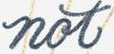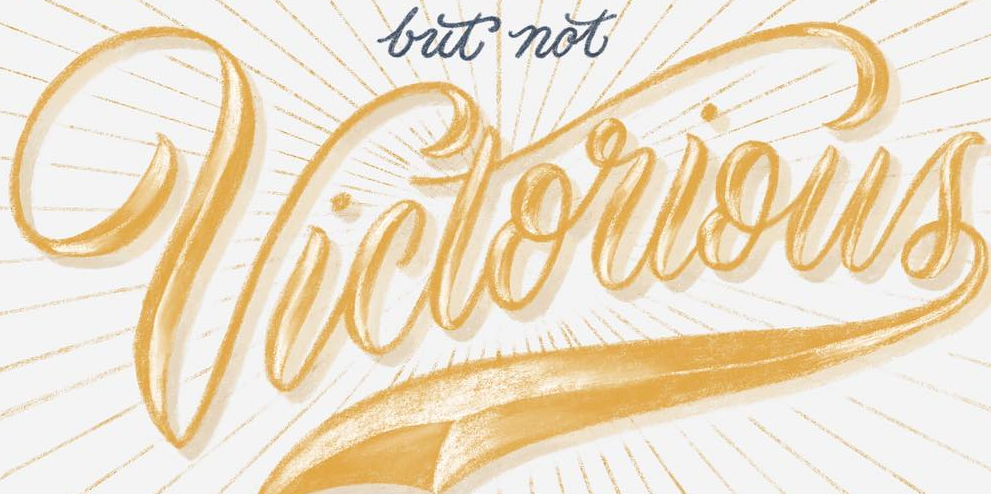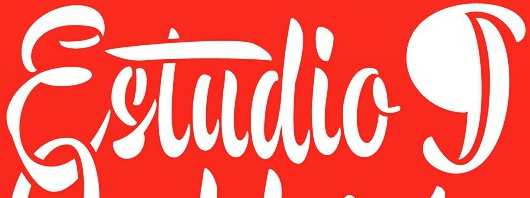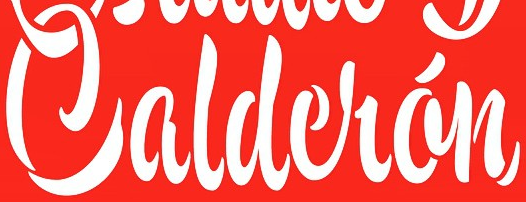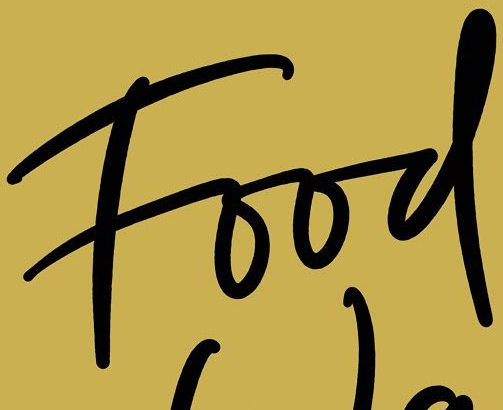What text is displayed in these images sequentially, separated by a semicolon? not; Victorious; Estudiog; Caldelán; Food 